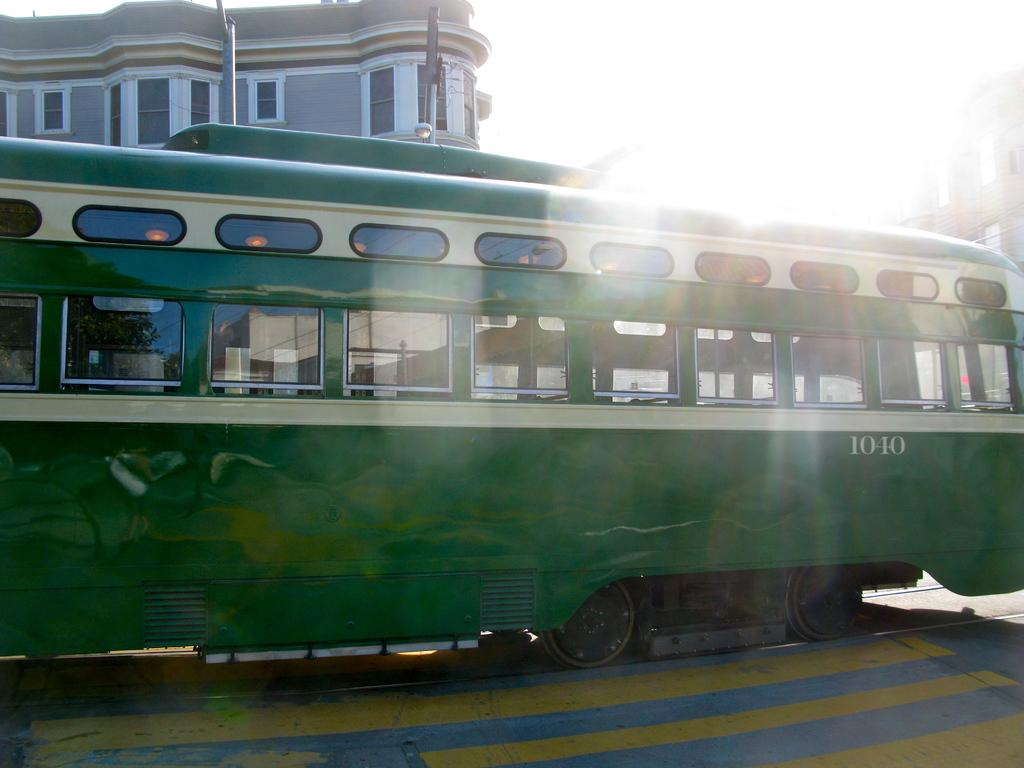<image>
Share a concise interpretation of the image provided. A bus with the number 1010 painted on its side. 